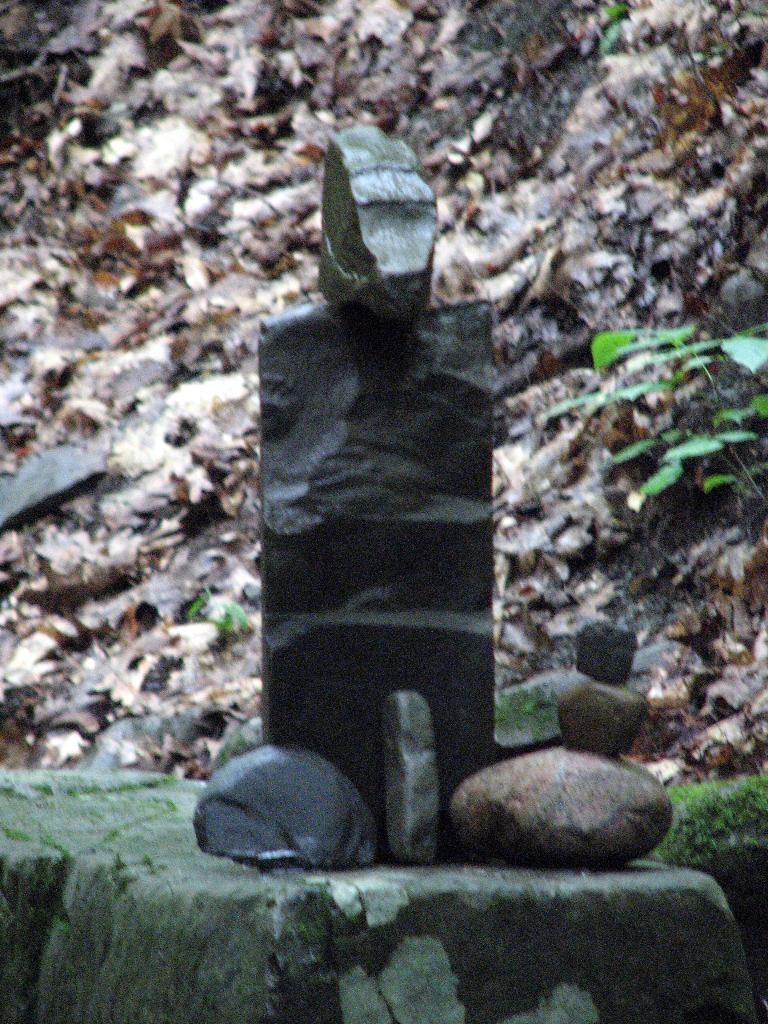What type of natural elements can be seen in the image? There are stones and plants in the image. Can you describe the stones in the image? The stones are visible in the image, but their specific characteristics are not mentioned in the provided facts. Are there any other objects or features in the background of the image? There might be a rock in the background of the image. How are the grains sorted in the image? There are no grains present in the image, so it is not possible to answer the question about sorting them. 